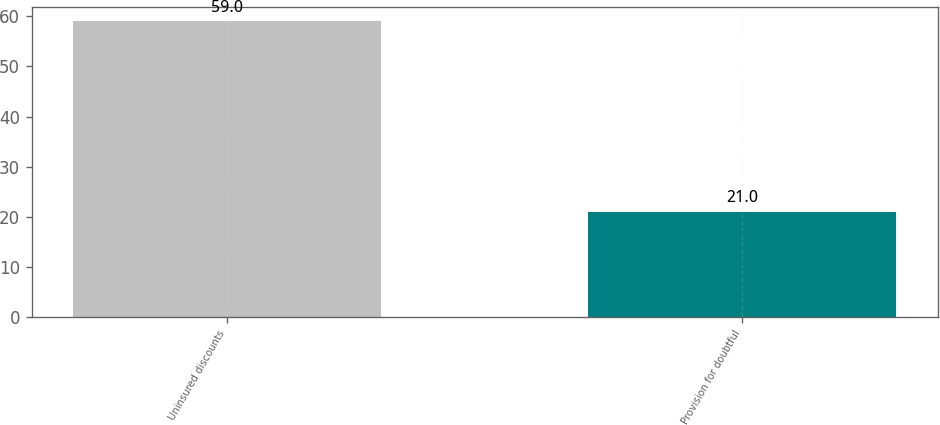Convert chart. <chart><loc_0><loc_0><loc_500><loc_500><bar_chart><fcel>Uninsured discounts<fcel>Provision for doubtful<nl><fcel>59<fcel>21<nl></chart> 